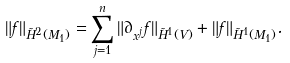<formula> <loc_0><loc_0><loc_500><loc_500>\| f \| _ { \tilde { H } ^ { 2 } ( M _ { 1 } ) } = \sum _ { j = 1 } ^ { n } \| \partial _ { x ^ { j } } f \| _ { \tilde { H } ^ { 1 } ( V ) } + \| f \| _ { \tilde { H } ^ { 1 } ( M _ { 1 } ) } .</formula> 